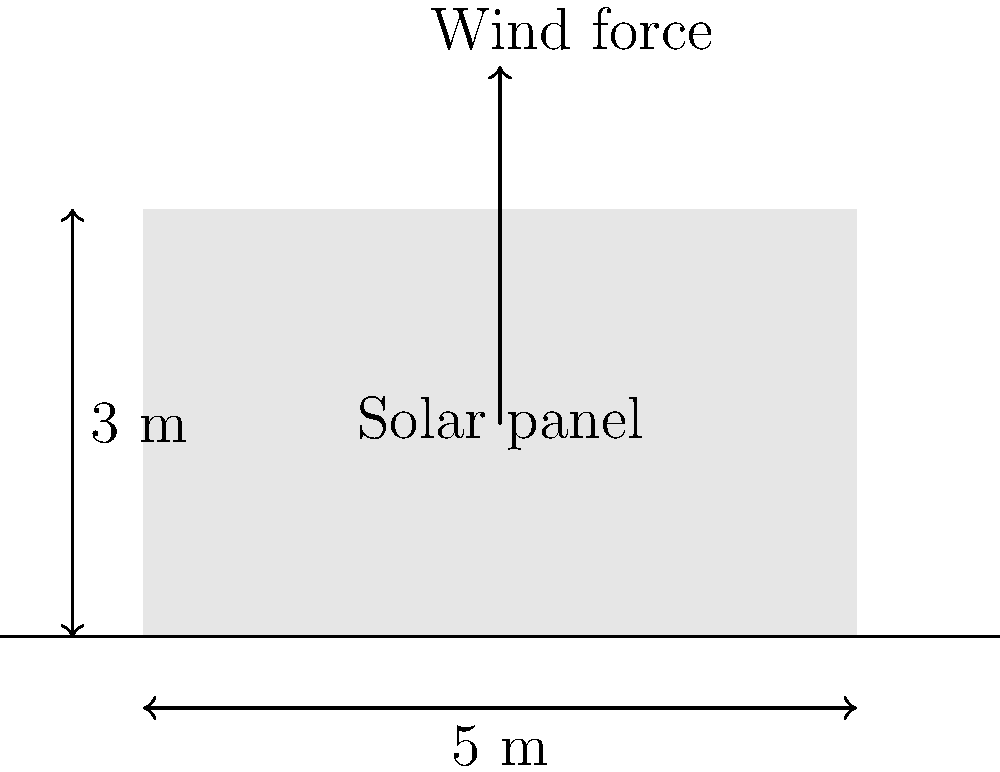A freestanding solar panel structure in a garden measures 5 m wide and 3 m high. If the wind pressure acting on the panel is 1.2 kN/m², calculate the total wind load on the structure. Assume the wind is acting perpendicular to the panel surface. To calculate the total wind load on the solar panel structure, we need to follow these steps:

1. Determine the area of the solar panel:
   Area = Width × Height
   $A = 5 \text{ m} \times 3 \text{ m} = 15 \text{ m}^2$

2. Identify the given wind pressure:
   $P = 1.2 \text{ kN/m}^2$

3. Calculate the total wind load using the formula:
   Wind Load = Pressure × Area
   $F = P \times A$

4. Substitute the values and compute:
   $F = 1.2 \text{ kN/m}^2 \times 15 \text{ m}^2 = 18 \text{ kN}$

Therefore, the total wind load acting on the solar panel structure is 18 kN.
Answer: 18 kN 